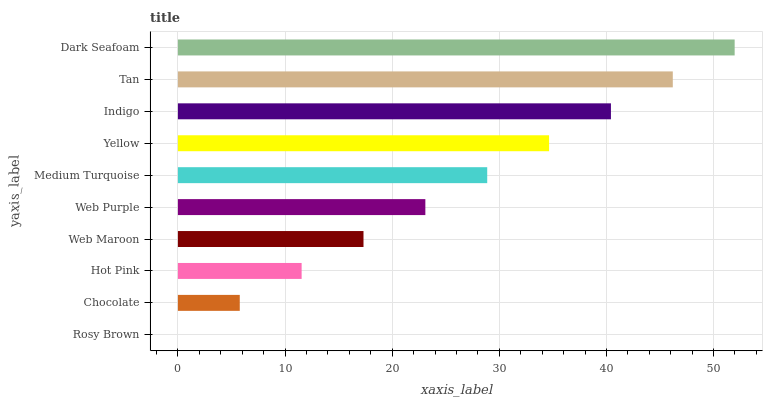Is Rosy Brown the minimum?
Answer yes or no. Yes. Is Dark Seafoam the maximum?
Answer yes or no. Yes. Is Chocolate the minimum?
Answer yes or no. No. Is Chocolate the maximum?
Answer yes or no. No. Is Chocolate greater than Rosy Brown?
Answer yes or no. Yes. Is Rosy Brown less than Chocolate?
Answer yes or no. Yes. Is Rosy Brown greater than Chocolate?
Answer yes or no. No. Is Chocolate less than Rosy Brown?
Answer yes or no. No. Is Medium Turquoise the high median?
Answer yes or no. Yes. Is Web Purple the low median?
Answer yes or no. Yes. Is Chocolate the high median?
Answer yes or no. No. Is Web Maroon the low median?
Answer yes or no. No. 